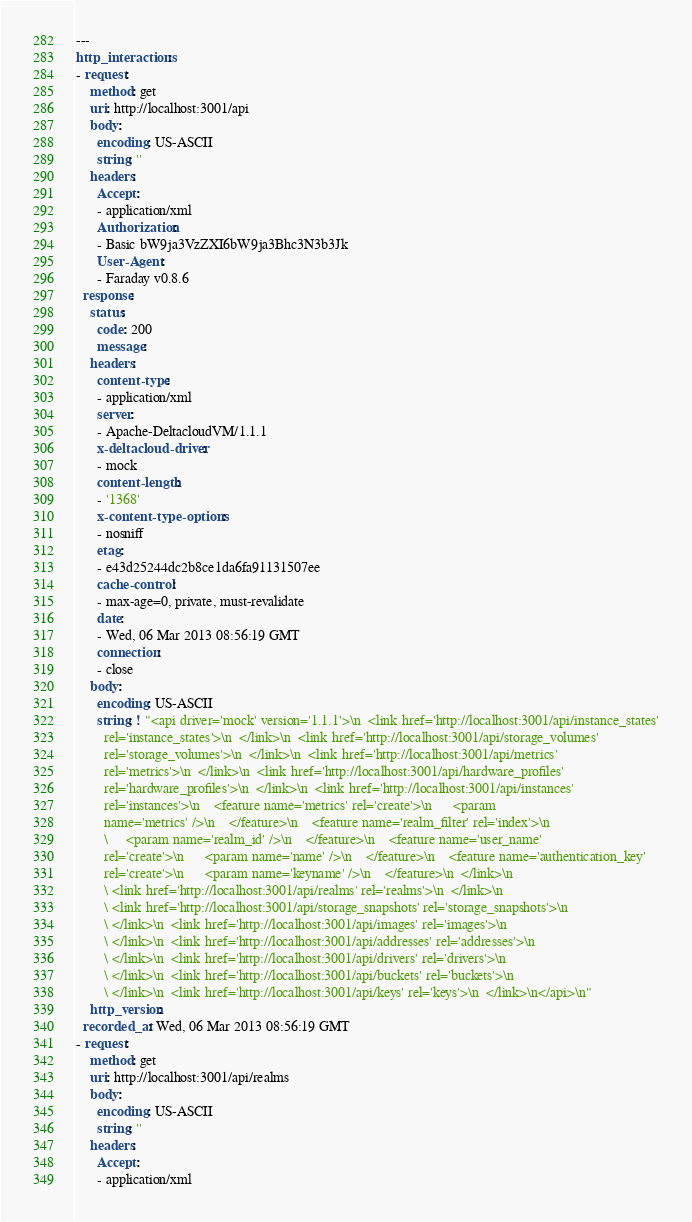Convert code to text. <code><loc_0><loc_0><loc_500><loc_500><_YAML_>---
http_interactions:
- request:
    method: get
    uri: http://localhost:3001/api
    body:
      encoding: US-ASCII
      string: ''
    headers:
      Accept:
      - application/xml
      Authorization:
      - Basic bW9ja3VzZXI6bW9ja3Bhc3N3b3Jk
      User-Agent:
      - Faraday v0.8.6
  response:
    status:
      code: 200
      message: 
    headers:
      content-type:
      - application/xml
      server:
      - Apache-DeltacloudVM/1.1.1
      x-deltacloud-driver:
      - mock
      content-length:
      - '1368'
      x-content-type-options:
      - nosniff
      etag:
      - e43d25244dc2b8ce1da6fa91131507ee
      cache-control:
      - max-age=0, private, must-revalidate
      date:
      - Wed, 06 Mar 2013 08:56:19 GMT
      connection:
      - close
    body:
      encoding: US-ASCII
      string: ! "<api driver='mock' version='1.1.1'>\n  <link href='http://localhost:3001/api/instance_states'
        rel='instance_states'>\n  </link>\n  <link href='http://localhost:3001/api/storage_volumes'
        rel='storage_volumes'>\n  </link>\n  <link href='http://localhost:3001/api/metrics'
        rel='metrics'>\n  </link>\n  <link href='http://localhost:3001/api/hardware_profiles'
        rel='hardware_profiles'>\n  </link>\n  <link href='http://localhost:3001/api/instances'
        rel='instances'>\n    <feature name='metrics' rel='create'>\n      <param
        name='metrics' />\n    </feature>\n    <feature name='realm_filter' rel='index'>\n
        \     <param name='realm_id' />\n    </feature>\n    <feature name='user_name'
        rel='create'>\n      <param name='name' />\n    </feature>\n    <feature name='authentication_key'
        rel='create'>\n      <param name='keyname' />\n    </feature>\n  </link>\n
        \ <link href='http://localhost:3001/api/realms' rel='realms'>\n  </link>\n
        \ <link href='http://localhost:3001/api/storage_snapshots' rel='storage_snapshots'>\n
        \ </link>\n  <link href='http://localhost:3001/api/images' rel='images'>\n
        \ </link>\n  <link href='http://localhost:3001/api/addresses' rel='addresses'>\n
        \ </link>\n  <link href='http://localhost:3001/api/drivers' rel='drivers'>\n
        \ </link>\n  <link href='http://localhost:3001/api/buckets' rel='buckets'>\n
        \ </link>\n  <link href='http://localhost:3001/api/keys' rel='keys'>\n  </link>\n</api>\n"
    http_version: 
  recorded_at: Wed, 06 Mar 2013 08:56:19 GMT
- request:
    method: get
    uri: http://localhost:3001/api/realms
    body:
      encoding: US-ASCII
      string: ''
    headers:
      Accept:
      - application/xml</code> 